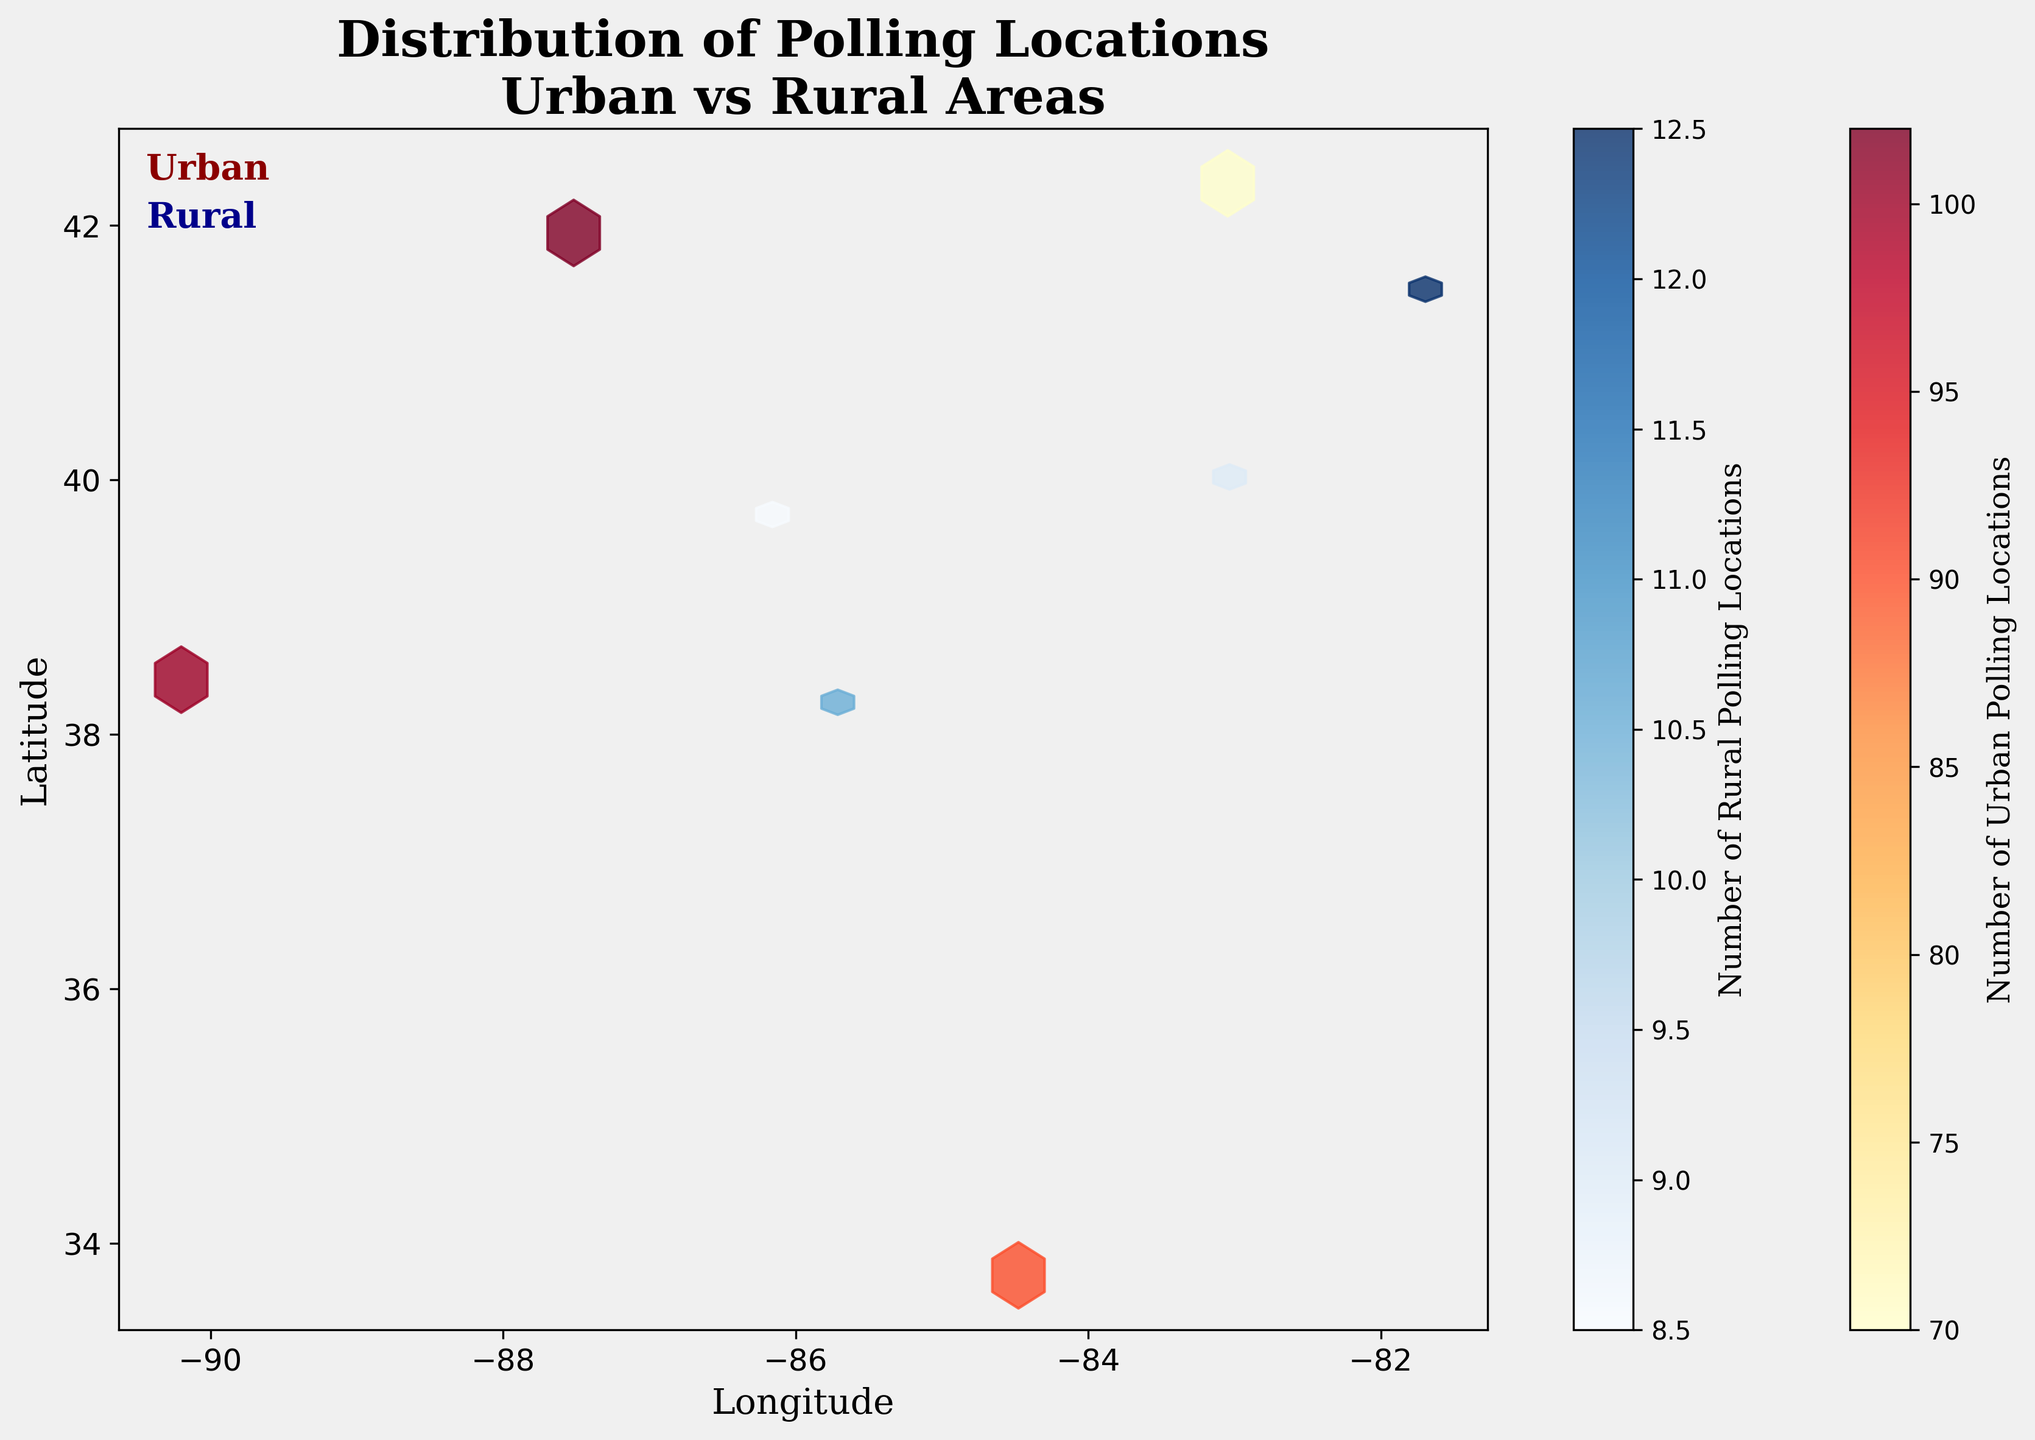What is the title of the plot? The title is typically located at the top of the figure and gives a summary of what the plot represents. Here, the title mentions the distribution of polling locations in urban vs. rural areas.
Answer: Distribution of Polling Locations Urban vs Rural Areas Which area type has the higher number of polling locations, urban or rural? By comparing the color intensity in the hexbin plot, it is apparent that urban areas have more polling locations as indicated by the denser and more vibrant hexagons.
Answer: Urban What colors represent urban and rural areas in the hexbin plot? Looking at the plot, urban areas are represented by shades of yellow and red, while rural areas are represented by shades of blue.
Answer: Yellow/Red for Urban, Blue for Rural What does the color intensity represent in this hexbin plot? In hexbin plots, color intensity usually represents the density or count of data points within each hexbin. The added color bars on the plot further confirm this interpretation.
Answer: Number of polling locations Which location has the highest number of urban polling locations? The plot indicates specific counts at various locations. By looking closely, Chicago (with coordinates -87.6298, 41.8781) has the highest counts going up to 150.
Answer: Chicago In which type of area do polling locations appear to be more widely spread out? Observing the hexbin density and spread, rural areas have polling locations that are more spread out, with fewer intense color hexagons, suggesting less clustering compared to urban areas.
Answer: Rural What is the range of the number of rural polling locations marked on the color bar? By looking at the color bar for rural areas on the right side of the plot, we see that the range is from 1 to 20.
Answer: 1 to 20 Looking at the hexbin density, in which particular geographic locations do urban polling locations cluster the most? By identifying clusters of dense hexagons, urban polling locations particularly cluster around Chicago, Atlanta, St. Louis, and Detroit.
Answer: Chicago, Atlanta, St. Louis, Detroit How would you describe the difference in polling locations between urban and rural areas? The hexbin plot shows a significant difference; urban areas have a high density of polling locations with intense colors, while rural areas are sparsely populated with lighter colored hexagons.
Answer: High density in urban, sparse in rural Considering the distribution in the plot, why might urban areas have more polling locations than rural areas? Urban areas have higher population densities which necessitate more polling locations to accommodate more voters. This is reflected in the dense clustering and high counts seen in the urban hexagons.
Answer: Higher population density in urban areas 